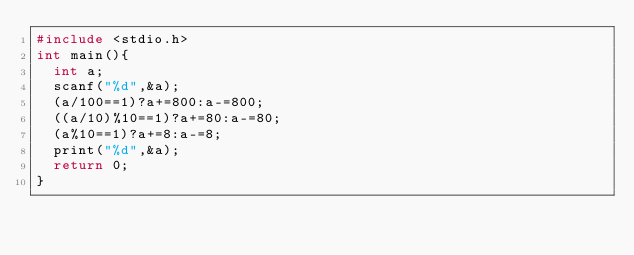<code> <loc_0><loc_0><loc_500><loc_500><_C_>#include <stdio.h>
int main(){
  int a;
  scanf("%d",&a);
  (a/100==1)?a+=800:a-=800;
  ((a/10)%10==1)?a+=80:a-=80;
  (a%10==1)?a+=8:a-=8;
  print("%d",&a);
  return 0;
}</code> 